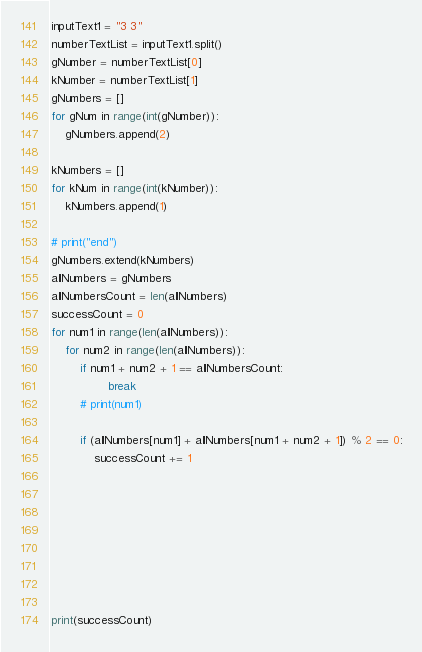Convert code to text. <code><loc_0><loc_0><loc_500><loc_500><_Python_>inputText1 = "3 3"
numberTextList = inputText1.split()
gNumber = numberTextList[0]
kNumber = numberTextList[1]
gNumbers = []
for gNum in range(int(gNumber)):
    gNumbers.append(2)

kNumbers = []
for kNum in range(int(kNumber)):
    kNumbers.append(1)

# print("end")
gNumbers.extend(kNumbers)
allNumbers = gNumbers
allNumbersCount = len(allNumbers)
successCount = 0
for num1 in range(len(allNumbers)):
    for num2 in range(len(allNumbers)):
        if num1 + num2 + 1 == allNumbersCount:
                break
        # print(num1)

        if (allNumbers[num1] + allNumbers[num1 + num2 + 1]) % 2 == 0:
            successCount += 1








print(successCount)
</code> 